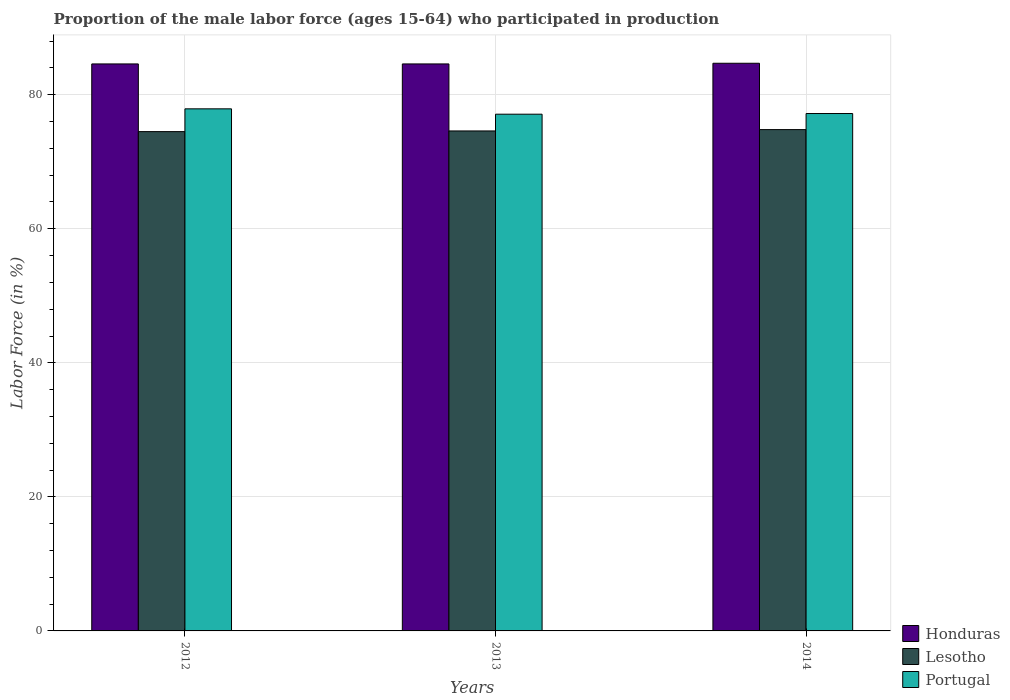How many groups of bars are there?
Provide a succinct answer. 3. Are the number of bars per tick equal to the number of legend labels?
Provide a short and direct response. Yes. Are the number of bars on each tick of the X-axis equal?
Your answer should be compact. Yes. What is the label of the 1st group of bars from the left?
Keep it short and to the point. 2012. In how many cases, is the number of bars for a given year not equal to the number of legend labels?
Your answer should be very brief. 0. What is the proportion of the male labor force who participated in production in Honduras in 2012?
Ensure brevity in your answer.  84.6. Across all years, what is the maximum proportion of the male labor force who participated in production in Honduras?
Provide a succinct answer. 84.7. Across all years, what is the minimum proportion of the male labor force who participated in production in Lesotho?
Keep it short and to the point. 74.5. In which year was the proportion of the male labor force who participated in production in Lesotho maximum?
Make the answer very short. 2014. In which year was the proportion of the male labor force who participated in production in Portugal minimum?
Ensure brevity in your answer.  2013. What is the total proportion of the male labor force who participated in production in Portugal in the graph?
Your answer should be very brief. 232.2. What is the difference between the proportion of the male labor force who participated in production in Portugal in 2013 and that in 2014?
Ensure brevity in your answer.  -0.1. What is the difference between the proportion of the male labor force who participated in production in Portugal in 2014 and the proportion of the male labor force who participated in production in Honduras in 2013?
Give a very brief answer. -7.4. What is the average proportion of the male labor force who participated in production in Honduras per year?
Offer a very short reply. 84.63. In the year 2012, what is the difference between the proportion of the male labor force who participated in production in Portugal and proportion of the male labor force who participated in production in Lesotho?
Give a very brief answer. 3.4. What is the ratio of the proportion of the male labor force who participated in production in Lesotho in 2012 to that in 2013?
Keep it short and to the point. 1. What is the difference between the highest and the second highest proportion of the male labor force who participated in production in Lesotho?
Your answer should be very brief. 0.2. What is the difference between the highest and the lowest proportion of the male labor force who participated in production in Lesotho?
Your answer should be compact. 0.3. Is the sum of the proportion of the male labor force who participated in production in Portugal in 2013 and 2014 greater than the maximum proportion of the male labor force who participated in production in Lesotho across all years?
Make the answer very short. Yes. What does the 1st bar from the left in 2012 represents?
Offer a terse response. Honduras. What does the 2nd bar from the right in 2013 represents?
Keep it short and to the point. Lesotho. Is it the case that in every year, the sum of the proportion of the male labor force who participated in production in Portugal and proportion of the male labor force who participated in production in Lesotho is greater than the proportion of the male labor force who participated in production in Honduras?
Ensure brevity in your answer.  Yes. How many bars are there?
Provide a succinct answer. 9. Are all the bars in the graph horizontal?
Your answer should be compact. No. Are the values on the major ticks of Y-axis written in scientific E-notation?
Offer a terse response. No. Does the graph contain grids?
Keep it short and to the point. Yes. How many legend labels are there?
Your answer should be very brief. 3. How are the legend labels stacked?
Your answer should be very brief. Vertical. What is the title of the graph?
Provide a succinct answer. Proportion of the male labor force (ages 15-64) who participated in production. What is the Labor Force (in %) of Honduras in 2012?
Give a very brief answer. 84.6. What is the Labor Force (in %) of Lesotho in 2012?
Offer a terse response. 74.5. What is the Labor Force (in %) in Portugal in 2012?
Give a very brief answer. 77.9. What is the Labor Force (in %) in Honduras in 2013?
Your response must be concise. 84.6. What is the Labor Force (in %) in Lesotho in 2013?
Keep it short and to the point. 74.6. What is the Labor Force (in %) of Portugal in 2013?
Make the answer very short. 77.1. What is the Labor Force (in %) in Honduras in 2014?
Provide a succinct answer. 84.7. What is the Labor Force (in %) in Lesotho in 2014?
Your answer should be compact. 74.8. What is the Labor Force (in %) of Portugal in 2014?
Ensure brevity in your answer.  77.2. Across all years, what is the maximum Labor Force (in %) of Honduras?
Give a very brief answer. 84.7. Across all years, what is the maximum Labor Force (in %) of Lesotho?
Your answer should be compact. 74.8. Across all years, what is the maximum Labor Force (in %) of Portugal?
Make the answer very short. 77.9. Across all years, what is the minimum Labor Force (in %) of Honduras?
Your answer should be compact. 84.6. Across all years, what is the minimum Labor Force (in %) in Lesotho?
Your answer should be compact. 74.5. Across all years, what is the minimum Labor Force (in %) in Portugal?
Offer a very short reply. 77.1. What is the total Labor Force (in %) of Honduras in the graph?
Keep it short and to the point. 253.9. What is the total Labor Force (in %) in Lesotho in the graph?
Offer a very short reply. 223.9. What is the total Labor Force (in %) of Portugal in the graph?
Provide a short and direct response. 232.2. What is the difference between the Labor Force (in %) in Honduras in 2012 and that in 2013?
Your answer should be compact. 0. What is the difference between the Labor Force (in %) in Lesotho in 2012 and that in 2013?
Keep it short and to the point. -0.1. What is the difference between the Labor Force (in %) in Portugal in 2012 and that in 2014?
Your response must be concise. 0.7. What is the difference between the Labor Force (in %) of Honduras in 2013 and that in 2014?
Your answer should be compact. -0.1. What is the difference between the Labor Force (in %) in Lesotho in 2013 and that in 2014?
Keep it short and to the point. -0.2. What is the difference between the Labor Force (in %) of Lesotho in 2012 and the Labor Force (in %) of Portugal in 2013?
Your answer should be very brief. -2.6. What is the difference between the Labor Force (in %) in Honduras in 2012 and the Labor Force (in %) in Lesotho in 2014?
Your response must be concise. 9.8. What is the difference between the Labor Force (in %) in Honduras in 2012 and the Labor Force (in %) in Portugal in 2014?
Ensure brevity in your answer.  7.4. What is the difference between the Labor Force (in %) in Honduras in 2013 and the Labor Force (in %) in Portugal in 2014?
Make the answer very short. 7.4. What is the difference between the Labor Force (in %) in Lesotho in 2013 and the Labor Force (in %) in Portugal in 2014?
Offer a terse response. -2.6. What is the average Labor Force (in %) of Honduras per year?
Ensure brevity in your answer.  84.63. What is the average Labor Force (in %) in Lesotho per year?
Ensure brevity in your answer.  74.63. What is the average Labor Force (in %) in Portugal per year?
Your answer should be compact. 77.4. In the year 2012, what is the difference between the Labor Force (in %) in Honduras and Labor Force (in %) in Portugal?
Your answer should be very brief. 6.7. In the year 2012, what is the difference between the Labor Force (in %) of Lesotho and Labor Force (in %) of Portugal?
Your answer should be very brief. -3.4. In the year 2013, what is the difference between the Labor Force (in %) of Honduras and Labor Force (in %) of Lesotho?
Your answer should be compact. 10. In the year 2013, what is the difference between the Labor Force (in %) in Honduras and Labor Force (in %) in Portugal?
Offer a terse response. 7.5. In the year 2013, what is the difference between the Labor Force (in %) in Lesotho and Labor Force (in %) in Portugal?
Ensure brevity in your answer.  -2.5. In the year 2014, what is the difference between the Labor Force (in %) of Honduras and Labor Force (in %) of Lesotho?
Your answer should be very brief. 9.9. In the year 2014, what is the difference between the Labor Force (in %) in Honduras and Labor Force (in %) in Portugal?
Your answer should be compact. 7.5. In the year 2014, what is the difference between the Labor Force (in %) in Lesotho and Labor Force (in %) in Portugal?
Keep it short and to the point. -2.4. What is the ratio of the Labor Force (in %) in Honduras in 2012 to that in 2013?
Offer a terse response. 1. What is the ratio of the Labor Force (in %) of Lesotho in 2012 to that in 2013?
Your answer should be compact. 1. What is the ratio of the Labor Force (in %) in Portugal in 2012 to that in 2013?
Ensure brevity in your answer.  1.01. What is the ratio of the Labor Force (in %) of Portugal in 2012 to that in 2014?
Offer a terse response. 1.01. What is the ratio of the Labor Force (in %) of Honduras in 2013 to that in 2014?
Ensure brevity in your answer.  1. What is the ratio of the Labor Force (in %) in Lesotho in 2013 to that in 2014?
Make the answer very short. 1. What is the difference between the highest and the second highest Labor Force (in %) of Lesotho?
Make the answer very short. 0.2. What is the difference between the highest and the second highest Labor Force (in %) of Portugal?
Offer a very short reply. 0.7. What is the difference between the highest and the lowest Labor Force (in %) of Lesotho?
Your answer should be very brief. 0.3. What is the difference between the highest and the lowest Labor Force (in %) of Portugal?
Give a very brief answer. 0.8. 